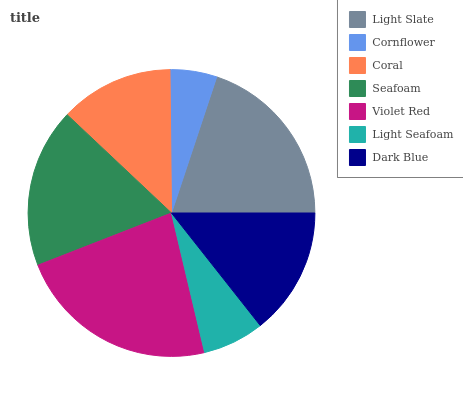Is Cornflower the minimum?
Answer yes or no. Yes. Is Violet Red the maximum?
Answer yes or no. Yes. Is Coral the minimum?
Answer yes or no. No. Is Coral the maximum?
Answer yes or no. No. Is Coral greater than Cornflower?
Answer yes or no. Yes. Is Cornflower less than Coral?
Answer yes or no. Yes. Is Cornflower greater than Coral?
Answer yes or no. No. Is Coral less than Cornflower?
Answer yes or no. No. Is Dark Blue the high median?
Answer yes or no. Yes. Is Dark Blue the low median?
Answer yes or no. Yes. Is Violet Red the high median?
Answer yes or no. No. Is Cornflower the low median?
Answer yes or no. No. 